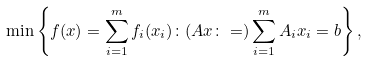Convert formula to latex. <formula><loc_0><loc_0><loc_500><loc_500>\min \left \{ f ( x ) = \sum _ { i = 1 } ^ { m } f _ { i } ( x _ { i } ) \colon ( A x \colon = ) \sum _ { i = 1 } ^ { m } A _ { i } x _ { i } = b \right \} ,</formula> 